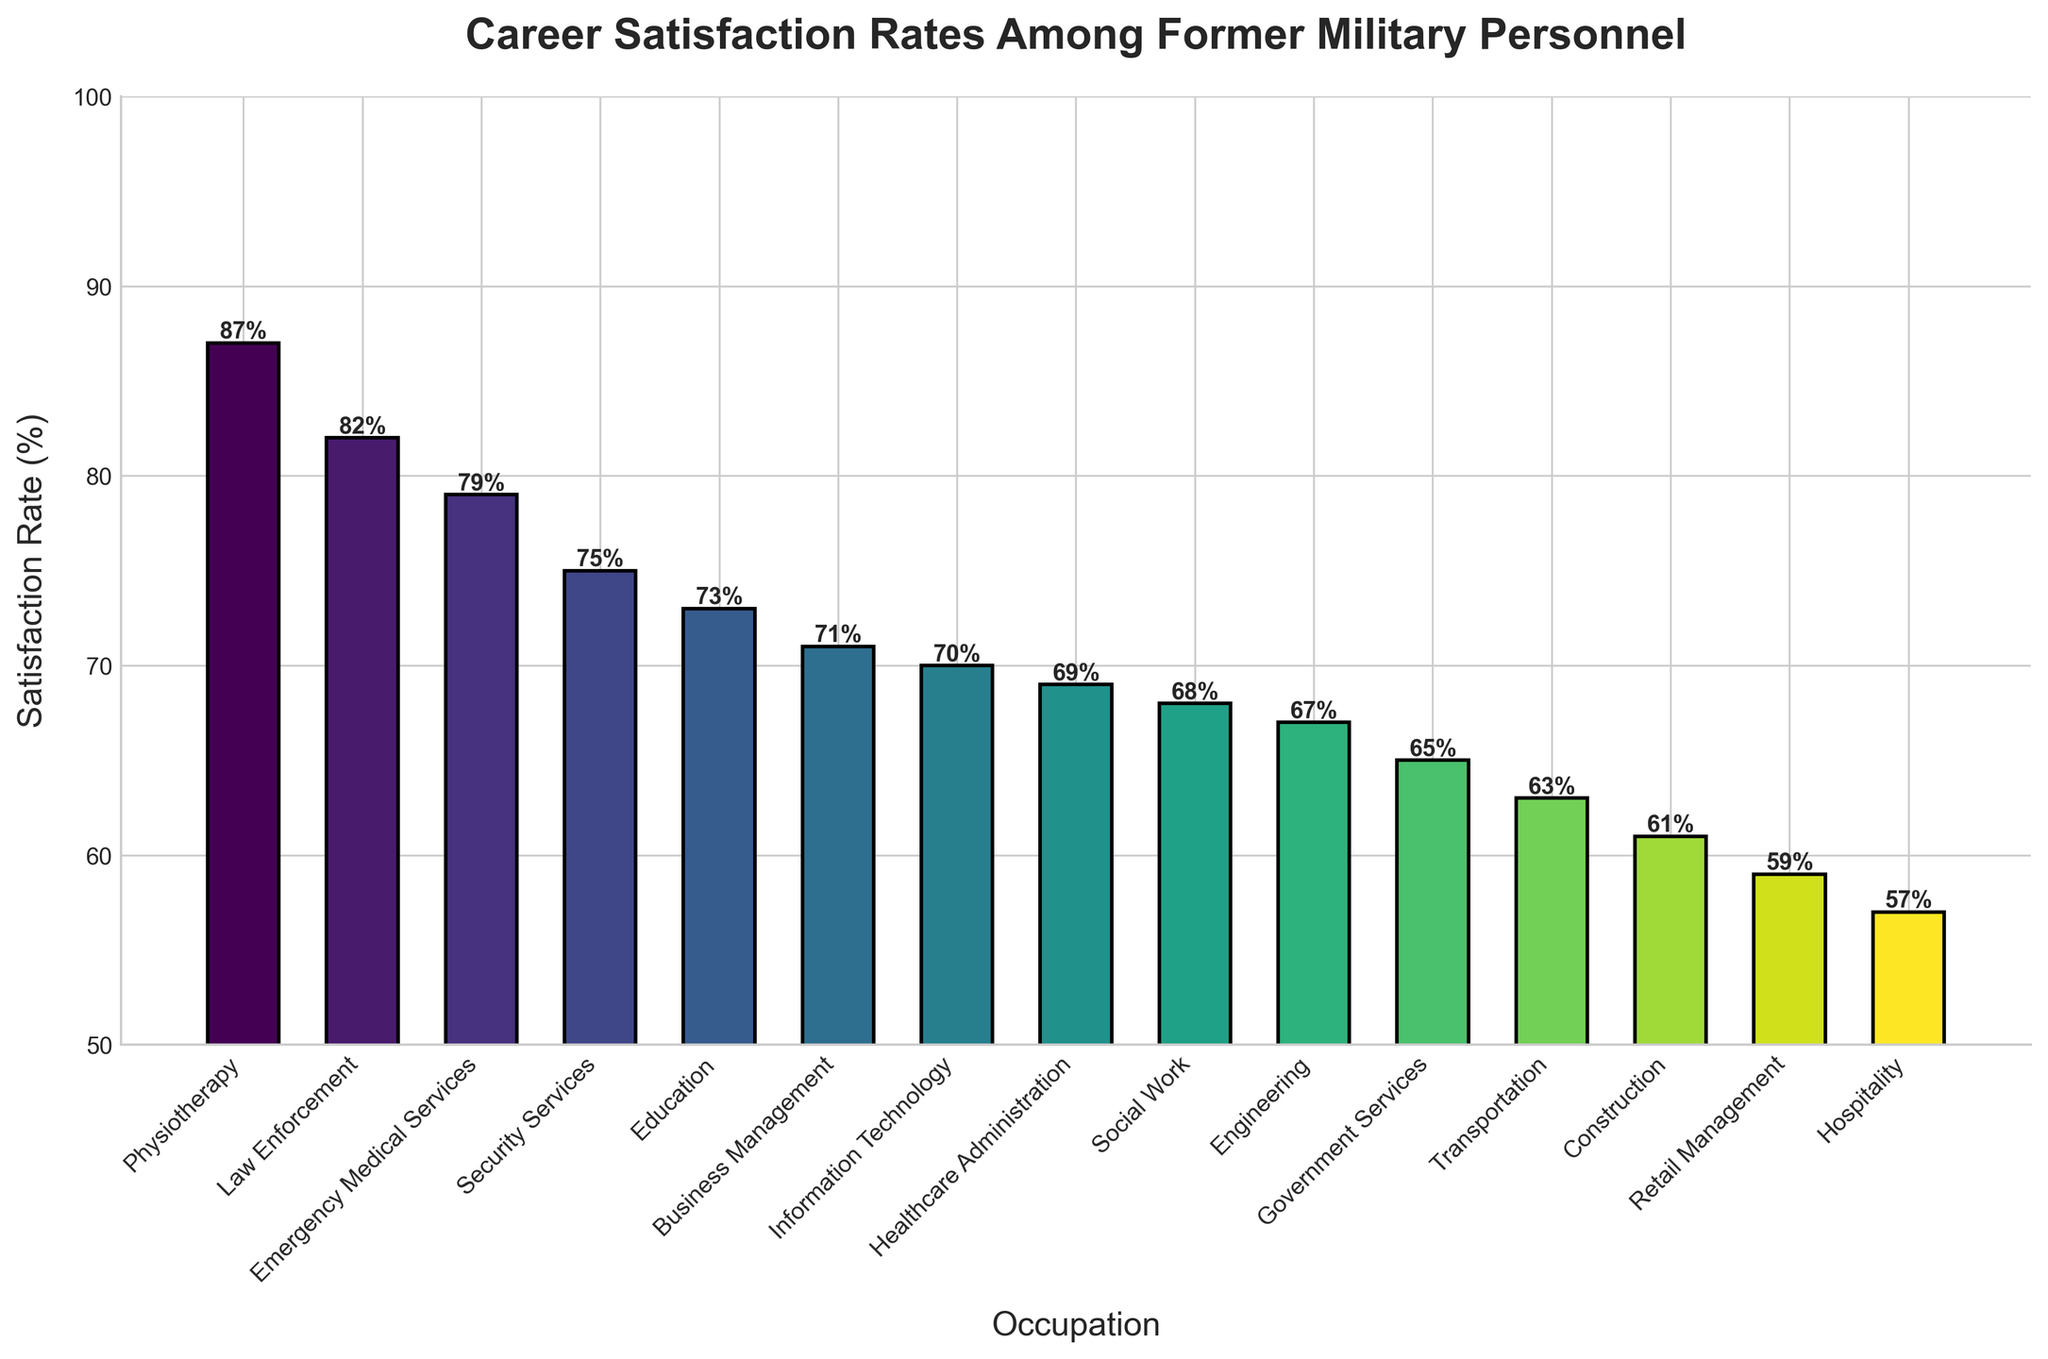What occupation has the highest career satisfaction rate among former military personnel? Look at the bar chart and identify the tallest bar. This bar represents the occupation with the highest satisfaction rate.
Answer: Physiotherapy Which occupation has a higher satisfaction rate: Education or Healthcare Administration? Locate the bars for both Education and Healthcare Administration on the chart. Education has a satisfaction rate of 73%, while Healthcare Administration has a rate of 69%. Education has a higher satisfaction rate.
Answer: Education How many occupations have a satisfaction rate above 75%? Count the bars that have a height indicating a satisfaction rate greater than 75%. These occupations are Physiotherapy, Law Enforcement, Emergency Medical Services, and Education. Thus, there are four such occupations.
Answer: 4 What is the average satisfaction rate for the occupations: Physiotherapy, Education, and Retail Management? Identify the satisfaction rates for these occupations (87%, 73%, and 59%). Calculate the average: (87 + 73 + 59) / 3 = 73.
Answer: 73 Compare the satisfaction rates between Transportation and Engineering. Which one is greater, and by how much? Locate the bars for Transportation and Engineering. The satisfaction rates are 63% and 67% respectively. Engineering has a greater satisfaction rate by 67% - 63% = 4%.
Answer: Engineering, 4% Which occupation is the closest in satisfaction rate to Social Work? Look at the satisfaction rate for Social Work (68%) and find the bar with the closest height. The closest rate is Healthcare Administration at 69%.
Answer: Healthcare Administration What's the difference in satisfaction rates between the highest (Physiotherapy) and the lowest (Hospitality) occupations? Identify the satisfaction rates for Physiotherapy (87%) and Hospitality (57%). The difference is 87% - 57% = 30%.
Answer: 30% How many occupations have satisfaction rates between 60% and 70%? Count the bars that have heights indicating satisfaction rates in the range of 60% to 70%. These are Healthcare Administration, Social Work, and Transportation, and Construction. So, there are four occupations in this range.
Answer: 4 Total satisfaction rate of Law Enforcement, Business Management, and Construction Identify the satisfaction rates for these occupations (82%, 71%, 61%). Sum them up: (82 + 71 + 61) = 214.
Answer: 214 Identify the range of satisfaction rates presented in the bar chart. Find the highest satisfaction rate (Physiotherapy, 87%) and the lowest (Hospitality, 57%), and calculate the range: 87% - 57% = 30%.
Answer: 30 